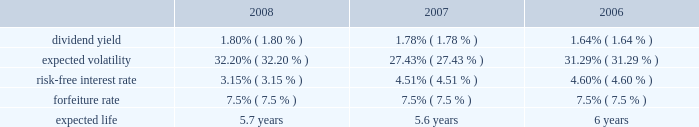N o t e s t o c o n s o l i d a t e d f i n a n c i a l s t a t e m e n t s ( continued ) ace limited and subsidiaries share-based compensation expense for stock options and shares issued under the employee stock purchase plan ( espp ) amounted to $ 24 million ( $ 22 million after tax or $ 0.07 per basic and diluted share ) , $ 23 million ( $ 21 million after tax or $ 0.06 per basic and diluted share ) , and $ 20 million ( $ 18 million after tax or $ 0.05 per basic and diluted share ) for the years ended december 31 , 2008 , 2007 , and 2006 , respectively .
For the years ended december 31 , 2008 , 2007 and 2006 , the expense for the restricted stock was $ 101 million ( $ 71 million after tax ) , $ 77 million ( $ 57 million after tax ) , and $ 65 million ( $ 49 million after tax ) , respectively .
During 2004 , the company established the ace limited 2004 long-term incentive plan ( the 2004 ltip ) .
Once the 2004 ltip was approved by shareholders , it became effective february 25 , 2004 .
It will continue in effect until terminated by the board .
This plan replaced the ace limited 1995 long-term incentive plan , the ace limited 1995 outside directors plan , the ace limited 1998 long-term incentive plan , and the ace limited 1999 replacement long-term incentive plan ( the prior plans ) except as to outstanding awards .
During the company 2019s 2008 annual general meeting , shareholders voted to increase the number of common shares authorized to be issued under the 2004 ltip from 15000000 common shares to 19000000 common shares .
Accordingly , under the 2004 ltip , a total of 19000000 common shares of the company are authorized to be issued pursuant to awards made as stock options , stock appreciation rights , performance shares , performance units , restricted stock , and restricted stock units .
The maximum number of shares that may be delivered to participants and their beneficiaries under the 2004 ltip shall be equal to the sum of : ( i ) 19000000 shares ; and ( ii ) any shares that are represented by awards granted under the prior plans that are forfeited , expired , or are canceled after the effective date of the 2004 ltip , without delivery of shares or which result in the forfeiture of the shares back to the company to the extent that such shares would have been added back to the reserve under the terms of the applicable prior plan .
As of december 31 , 2008 , a total of 10591090 shares remain available for future issuance under this plan .
Under the 2004 ltip , 3000000 common shares are authorized to be issued under the espp .
As of december 31 , 2008 , a total of 989812 common shares remain available for issuance under the espp .
Stock options the company 2019s 2004 ltip provides for grants of both incentive and non-qualified stock options principally at an option price per share of 100 percent of the fair value of the company 2019s common shares on the date of grant .
Stock options are generally granted with a 3-year vesting period and a 10-year term .
The stock options vest in equal annual installments over the respective vesting period , which is also the requisite service period .
Included in the company 2019s share-based compensation expense in the year ended december 31 , 2008 , is the cost related to the unvested portion of the 2005-2008 stock option grants .
The fair value of the stock options was estimated on the date of grant using the black-scholes option-pricing model that uses the assumptions noted in the table .
The risk-free inter- est rate is based on the u.s .
Treasury yield curve in effect at the time of grant .
The expected life ( estimated period of time from grant to exercise date ) was estimated using the historical exercise behavior of employees .
Expected volatility was calculated as a blend of ( a ) historical volatility based on daily closing prices over a period equal to the expected life assumption , ( b ) long- term historical volatility based on daily closing prices over the period from ace 2019s initial public trading date through the most recent quarter , and ( c ) implied volatility derived from ace 2019s publicly traded options .
The fair value of the options issued is estimated on the date of grant using the black-scholes option-pricing model , with the following weighted-average assumptions used for grants for the years indicated: .

What is the percentage change in dividend yield from 2007 to 2008? 
Computations: ((1.80 - 1.78) / 1.78)
Answer: 0.01124. 